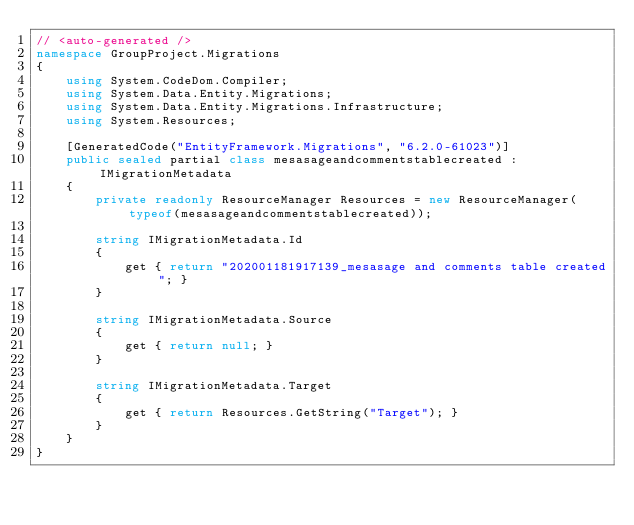<code> <loc_0><loc_0><loc_500><loc_500><_C#_>// <auto-generated />
namespace GroupProject.Migrations
{
    using System.CodeDom.Compiler;
    using System.Data.Entity.Migrations;
    using System.Data.Entity.Migrations.Infrastructure;
    using System.Resources;
    
    [GeneratedCode("EntityFramework.Migrations", "6.2.0-61023")]
    public sealed partial class mesasageandcommentstablecreated : IMigrationMetadata
    {
        private readonly ResourceManager Resources = new ResourceManager(typeof(mesasageandcommentstablecreated));
        
        string IMigrationMetadata.Id
        {
            get { return "202001181917139_mesasage and comments table created"; }
        }
        
        string IMigrationMetadata.Source
        {
            get { return null; }
        }
        
        string IMigrationMetadata.Target
        {
            get { return Resources.GetString("Target"); }
        }
    }
}
</code> 